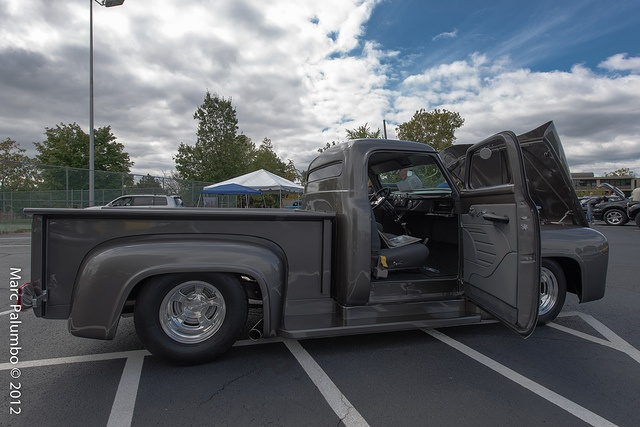Describe the objects in this image and their specific colors. I can see truck in lightgray, black, gray, and darkgray tones, chair in lightgray, black, gray, and olive tones, car in lightgray, black, gray, and purple tones, car in lightgray, gray, black, and darkgray tones, and people in lightgray, black, gray, and darkblue tones in this image. 